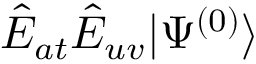Convert formula to latex. <formula><loc_0><loc_0><loc_500><loc_500>\hat { E } _ { a t } \hat { E } _ { u v } | \Psi ^ { ( 0 ) } \rangle</formula> 